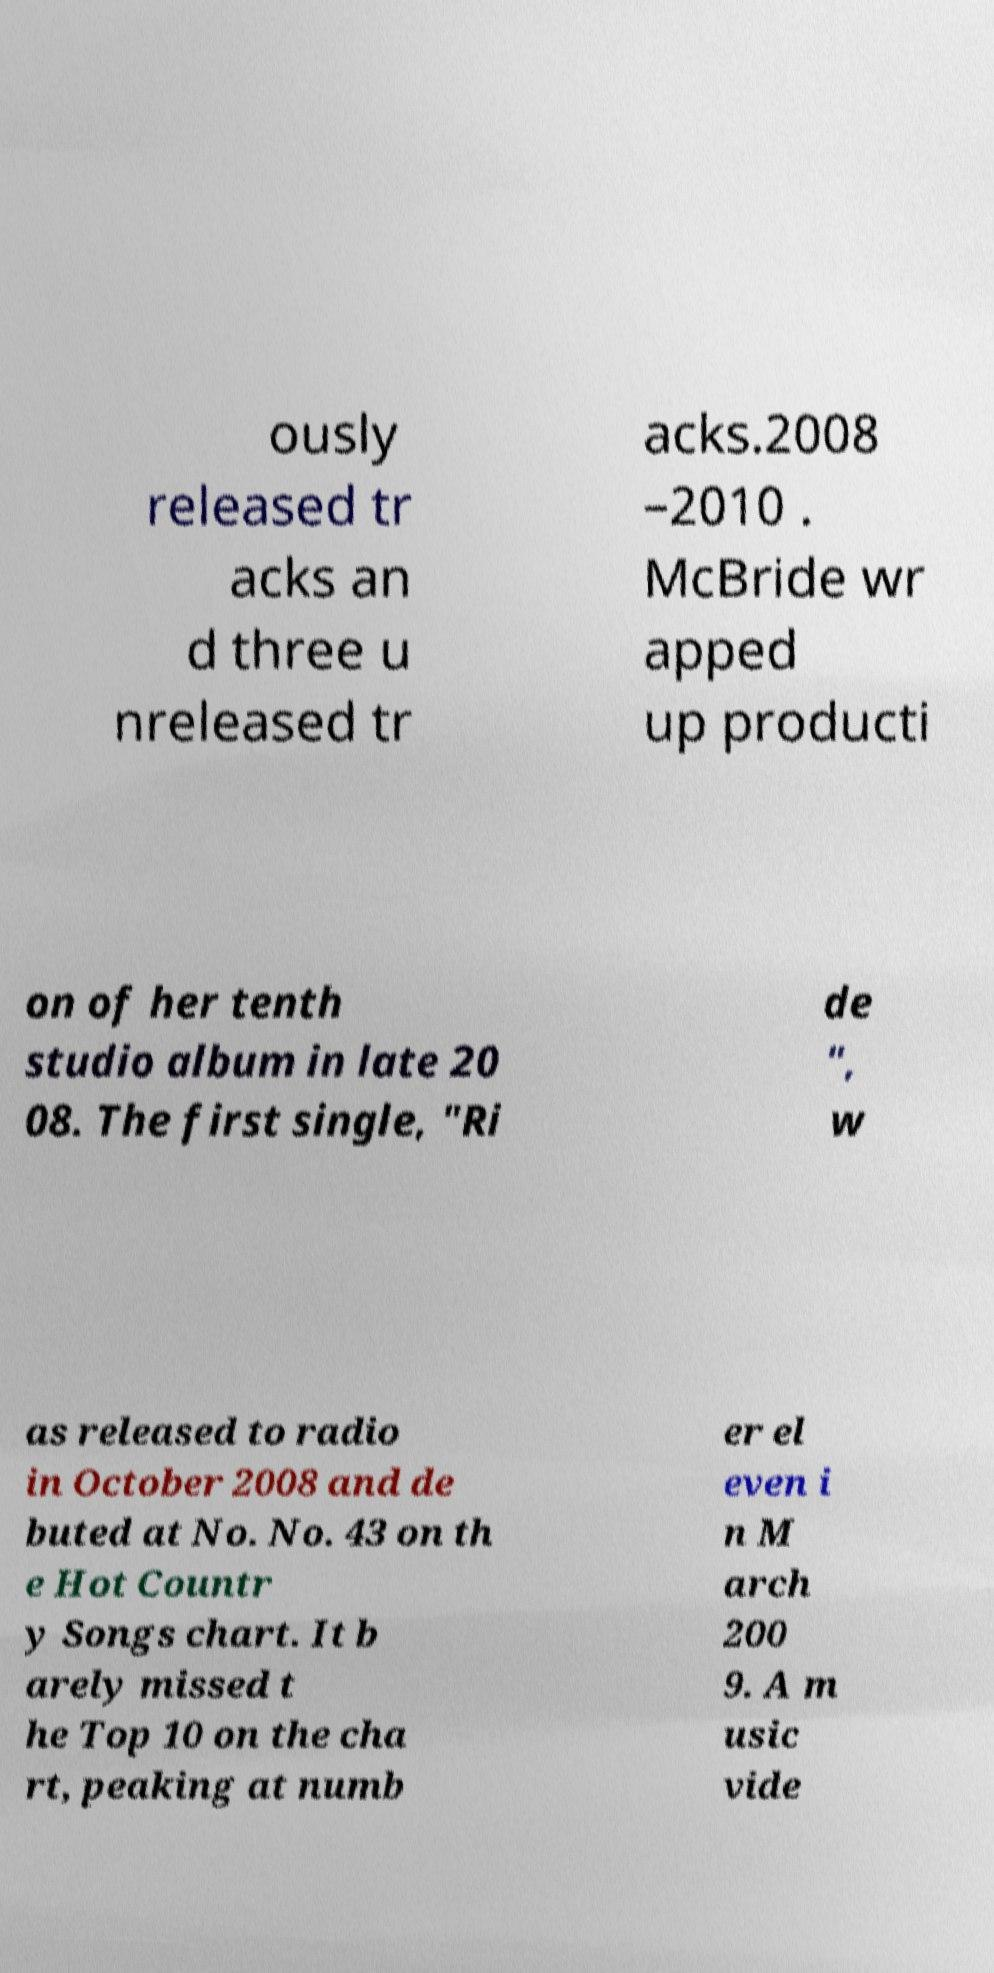For documentation purposes, I need the text within this image transcribed. Could you provide that? ously released tr acks an d three u nreleased tr acks.2008 –2010 . McBride wr apped up producti on of her tenth studio album in late 20 08. The first single, "Ri de ", w as released to radio in October 2008 and de buted at No. No. 43 on th e Hot Countr y Songs chart. It b arely missed t he Top 10 on the cha rt, peaking at numb er el even i n M arch 200 9. A m usic vide 